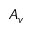<formula> <loc_0><loc_0><loc_500><loc_500>A _ { v }</formula> 